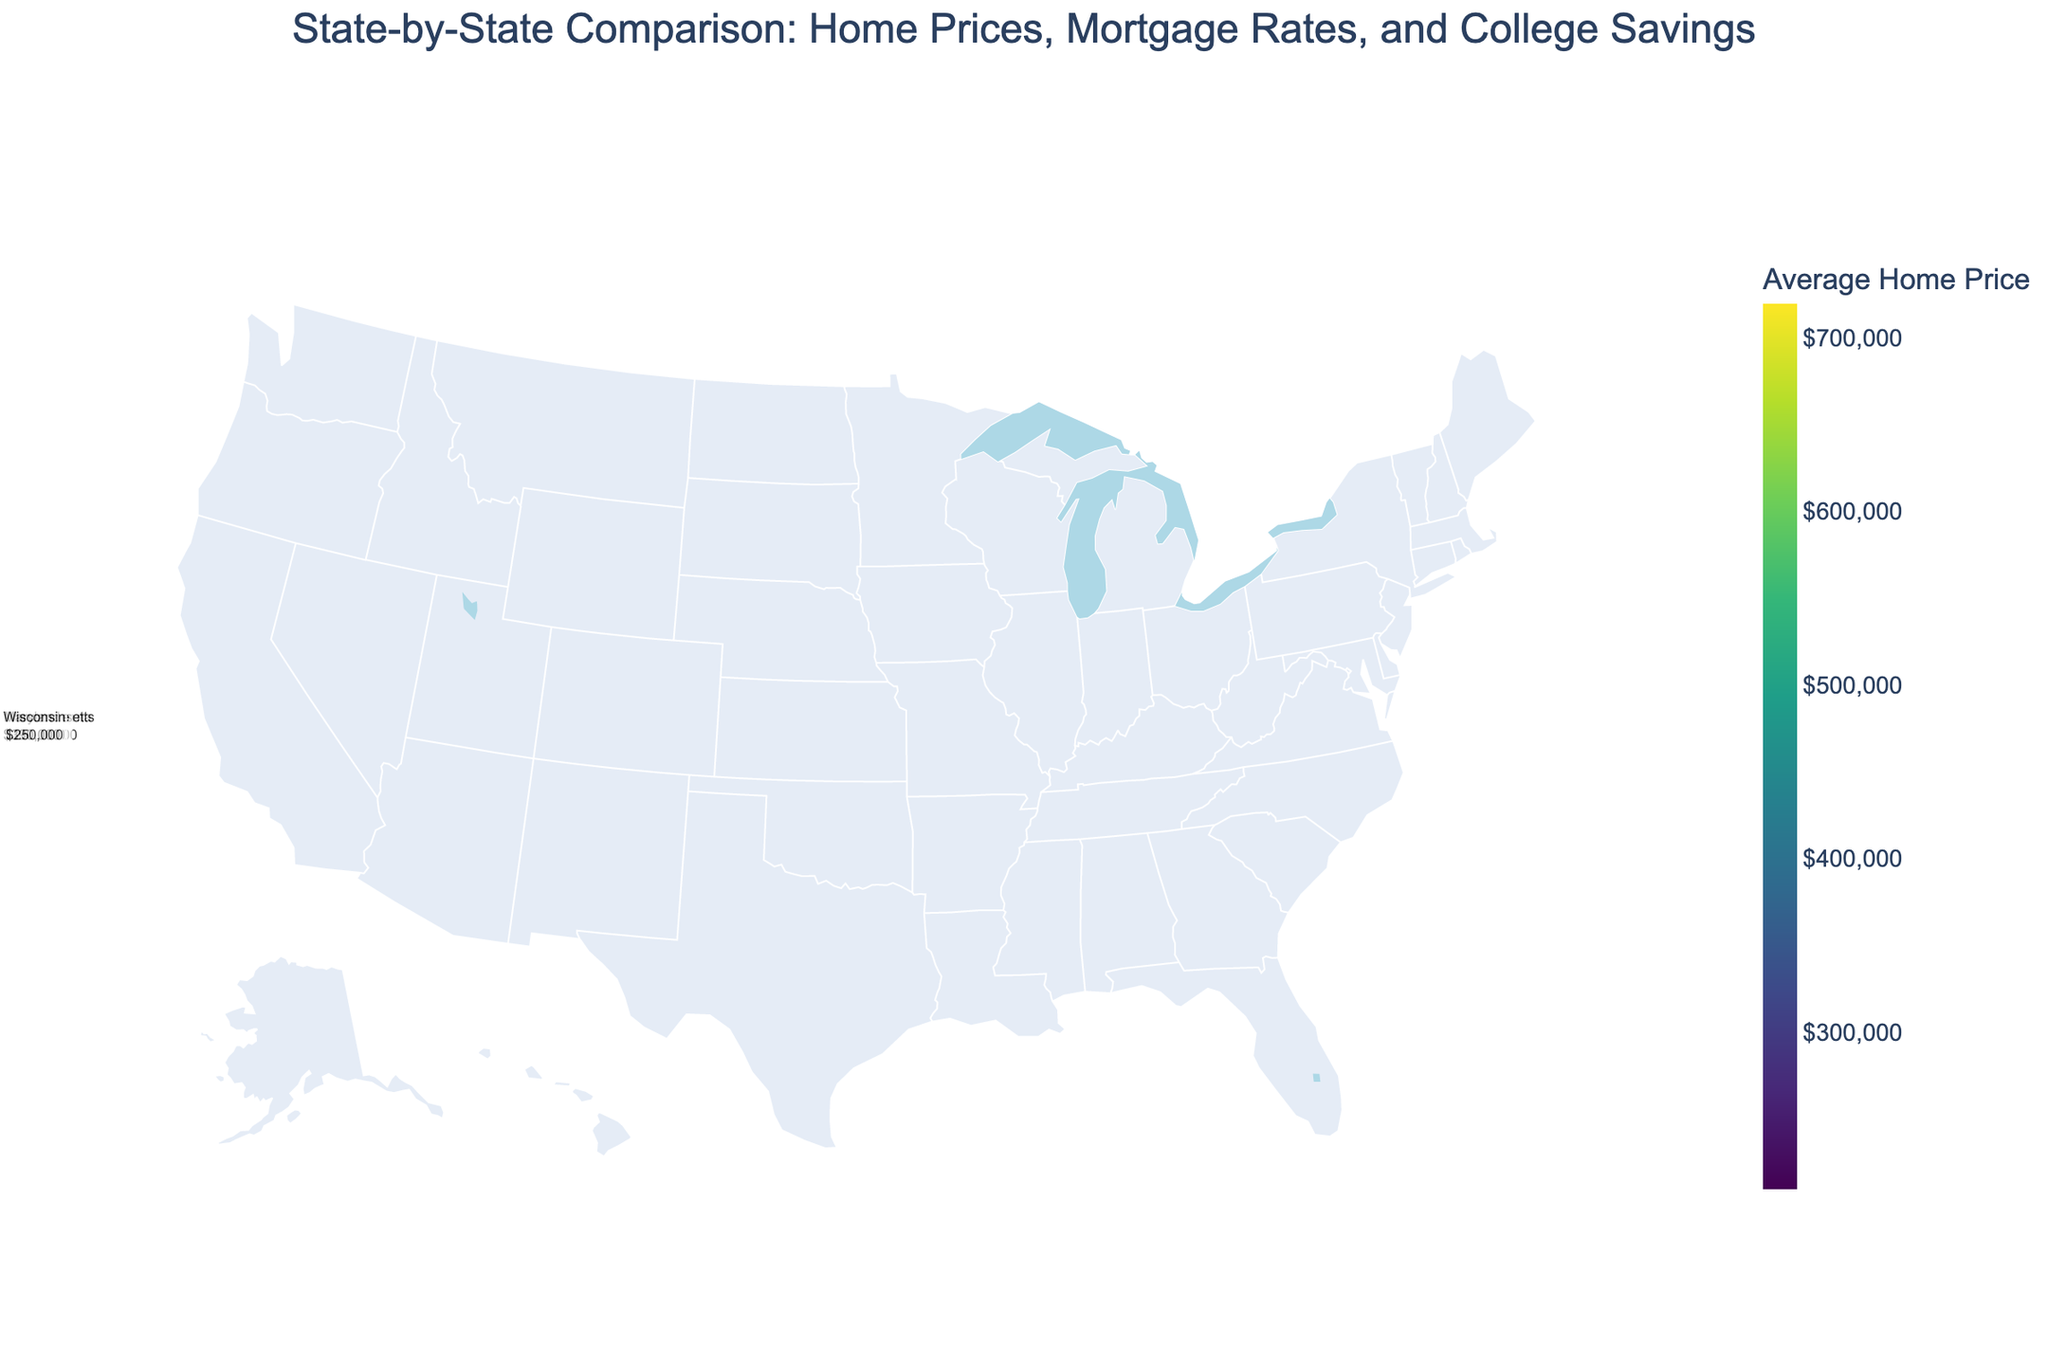What’s the average home price in California? Find California on the map, hover over it to see the average home price in the tooltip.
Answer: $685,000 Which state has the highest mortgage interest rate? Identify the state with the darkest color or highest value in the tooltip. New York has the highest mortgage interest rate of 6.9%.
Answer: New York How does Florida’s college savings index compare to Georgia’s? Hover over Florida and Georgia, then compare the values shown in the tooltips. Florida has a value of 75, and Georgia has 77.
Answer: Florida's index is lower Is the average home price in New Jersey higher than the national average? Find New Jersey on the map and check its average home price ($465,000). Calculate the national average by summing up all state home prices and dividing by the number of states.
Answer: Depends on national average but likely yes given NJ's high price Which state has the lowest average home price? Identify the state with the lightest color or lowest value in the tooltip. Ohio has the lowest average home price of $210,000.
Answer: Ohio Compare the mortgage interest rates between Texas and Michigan? Hover over Texas and Michigan to compare their interest rates. Texas's rate is 6.5% and Michigan's rate is 6.3%.
Answer: Texas's rate is higher If you want to save more on a mortgage, should you consider moving to Illinois or Massachusetts? Compare the mortgage interest rates between Illinois (6.4%) and Massachusetts (6.7%).
Answer: Illinois What's the general trend among states with high home prices in terms of mortgage interest rates? Look at states with high home prices like California, New York, and Washington and note their interest rates.
Answer: Higher home prices tend to have higher interest rates Which state has similar average home prices to Virginia but a lower mortgage interest rate? Look for states with home prices close to $375,000 and compare their interest rates. North Carolina has $305,000 with a 6.4% rate.
Answer: North Carolina How do the average home prices in Arizona and Maryland compare? Hover over Arizona and Maryland to compare average home prices. Arizona's price is $425,000 and Maryland's is $390,000.
Answer: Arizona's price is higher 